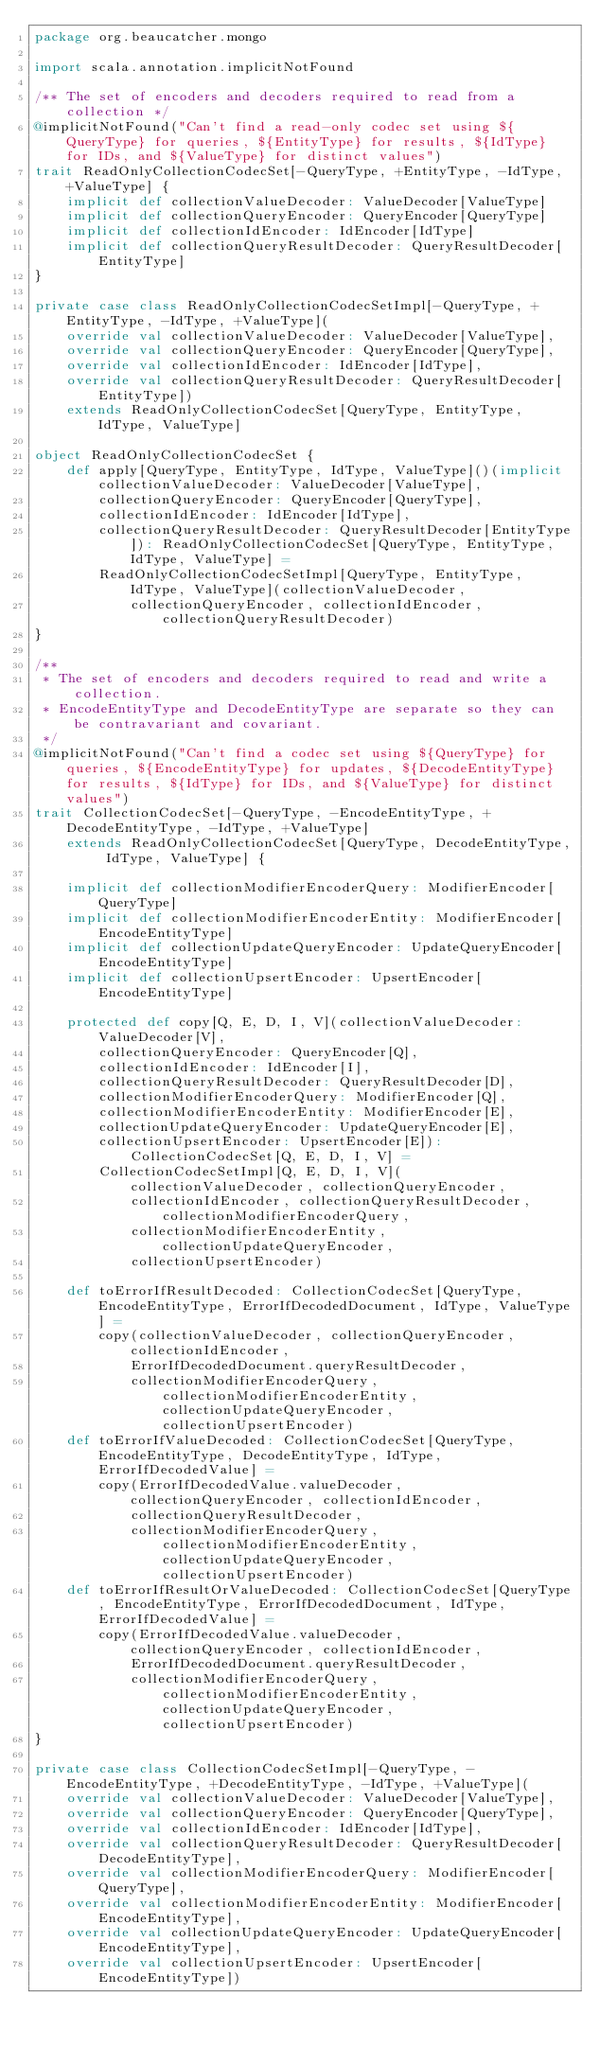Convert code to text. <code><loc_0><loc_0><loc_500><loc_500><_Scala_>package org.beaucatcher.mongo

import scala.annotation.implicitNotFound

/** The set of encoders and decoders required to read from a collection */
@implicitNotFound("Can't find a read-only codec set using ${QueryType} for queries, ${EntityType} for results, ${IdType} for IDs, and ${ValueType} for distinct values")
trait ReadOnlyCollectionCodecSet[-QueryType, +EntityType, -IdType, +ValueType] {
    implicit def collectionValueDecoder: ValueDecoder[ValueType]
    implicit def collectionQueryEncoder: QueryEncoder[QueryType]
    implicit def collectionIdEncoder: IdEncoder[IdType]
    implicit def collectionQueryResultDecoder: QueryResultDecoder[EntityType]
}

private case class ReadOnlyCollectionCodecSetImpl[-QueryType, +EntityType, -IdType, +ValueType](
    override val collectionValueDecoder: ValueDecoder[ValueType],
    override val collectionQueryEncoder: QueryEncoder[QueryType],
    override val collectionIdEncoder: IdEncoder[IdType],
    override val collectionQueryResultDecoder: QueryResultDecoder[EntityType])
    extends ReadOnlyCollectionCodecSet[QueryType, EntityType, IdType, ValueType]

object ReadOnlyCollectionCodecSet {
    def apply[QueryType, EntityType, IdType, ValueType]()(implicit collectionValueDecoder: ValueDecoder[ValueType],
        collectionQueryEncoder: QueryEncoder[QueryType],
        collectionIdEncoder: IdEncoder[IdType],
        collectionQueryResultDecoder: QueryResultDecoder[EntityType]): ReadOnlyCollectionCodecSet[QueryType, EntityType, IdType, ValueType] =
        ReadOnlyCollectionCodecSetImpl[QueryType, EntityType, IdType, ValueType](collectionValueDecoder,
            collectionQueryEncoder, collectionIdEncoder, collectionQueryResultDecoder)
}

/**
 * The set of encoders and decoders required to read and write a collection.
 * EncodeEntityType and DecodeEntityType are separate so they can be contravariant and covariant.
 */
@implicitNotFound("Can't find a codec set using ${QueryType} for queries, ${EncodeEntityType} for updates, ${DecodeEntityType} for results, ${IdType} for IDs, and ${ValueType} for distinct values")
trait CollectionCodecSet[-QueryType, -EncodeEntityType, +DecodeEntityType, -IdType, +ValueType]
    extends ReadOnlyCollectionCodecSet[QueryType, DecodeEntityType, IdType, ValueType] {

    implicit def collectionModifierEncoderQuery: ModifierEncoder[QueryType]
    implicit def collectionModifierEncoderEntity: ModifierEncoder[EncodeEntityType]
    implicit def collectionUpdateQueryEncoder: UpdateQueryEncoder[EncodeEntityType]
    implicit def collectionUpsertEncoder: UpsertEncoder[EncodeEntityType]

    protected def copy[Q, E, D, I, V](collectionValueDecoder: ValueDecoder[V],
        collectionQueryEncoder: QueryEncoder[Q],
        collectionIdEncoder: IdEncoder[I],
        collectionQueryResultDecoder: QueryResultDecoder[D],
        collectionModifierEncoderQuery: ModifierEncoder[Q],
        collectionModifierEncoderEntity: ModifierEncoder[E],
        collectionUpdateQueryEncoder: UpdateQueryEncoder[E],
        collectionUpsertEncoder: UpsertEncoder[E]): CollectionCodecSet[Q, E, D, I, V] =
        CollectionCodecSetImpl[Q, E, D, I, V](collectionValueDecoder, collectionQueryEncoder,
            collectionIdEncoder, collectionQueryResultDecoder, collectionModifierEncoderQuery,
            collectionModifierEncoderEntity, collectionUpdateQueryEncoder,
            collectionUpsertEncoder)

    def toErrorIfResultDecoded: CollectionCodecSet[QueryType, EncodeEntityType, ErrorIfDecodedDocument, IdType, ValueType] =
        copy(collectionValueDecoder, collectionQueryEncoder, collectionIdEncoder,
            ErrorIfDecodedDocument.queryResultDecoder,
            collectionModifierEncoderQuery, collectionModifierEncoderEntity, collectionUpdateQueryEncoder, collectionUpsertEncoder)
    def toErrorIfValueDecoded: CollectionCodecSet[QueryType, EncodeEntityType, DecodeEntityType, IdType, ErrorIfDecodedValue] =
        copy(ErrorIfDecodedValue.valueDecoder, collectionQueryEncoder, collectionIdEncoder,
            collectionQueryResultDecoder,
            collectionModifierEncoderQuery, collectionModifierEncoderEntity, collectionUpdateQueryEncoder, collectionUpsertEncoder)
    def toErrorIfResultOrValueDecoded: CollectionCodecSet[QueryType, EncodeEntityType, ErrorIfDecodedDocument, IdType, ErrorIfDecodedValue] =
        copy(ErrorIfDecodedValue.valueDecoder, collectionQueryEncoder, collectionIdEncoder,
            ErrorIfDecodedDocument.queryResultDecoder,
            collectionModifierEncoderQuery, collectionModifierEncoderEntity, collectionUpdateQueryEncoder, collectionUpsertEncoder)
}

private case class CollectionCodecSetImpl[-QueryType, -EncodeEntityType, +DecodeEntityType, -IdType, +ValueType](
    override val collectionValueDecoder: ValueDecoder[ValueType],
    override val collectionQueryEncoder: QueryEncoder[QueryType],
    override val collectionIdEncoder: IdEncoder[IdType],
    override val collectionQueryResultDecoder: QueryResultDecoder[DecodeEntityType],
    override val collectionModifierEncoderQuery: ModifierEncoder[QueryType],
    override val collectionModifierEncoderEntity: ModifierEncoder[EncodeEntityType],
    override val collectionUpdateQueryEncoder: UpdateQueryEncoder[EncodeEntityType],
    override val collectionUpsertEncoder: UpsertEncoder[EncodeEntityType])</code> 